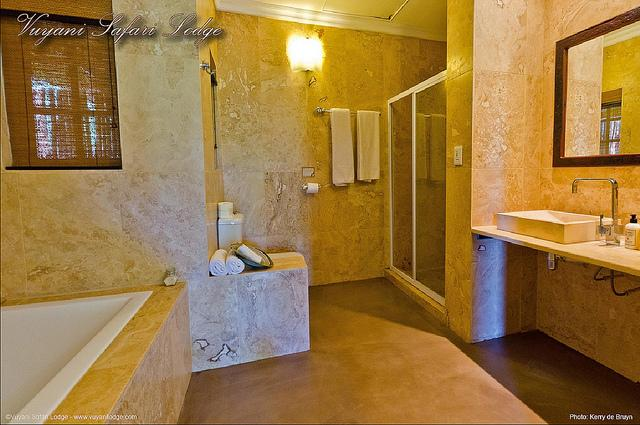What color is the lamp on the top of the wall next to the shower?

Choices:
A) yellow
B) blue
C) red
D) white yellow 